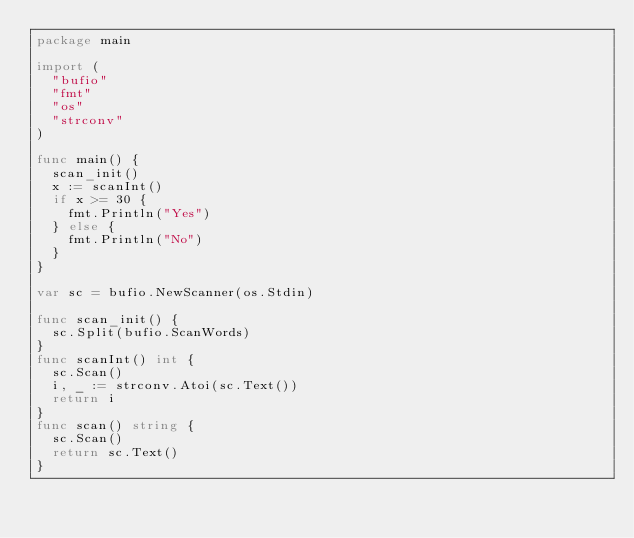<code> <loc_0><loc_0><loc_500><loc_500><_Go_>package main

import (
	"bufio"
	"fmt"
	"os"
	"strconv"
)

func main() {
	scan_init()
	x := scanInt()
	if x >= 30 {
		fmt.Println("Yes")
	} else {
		fmt.Println("No")
	}
}

var sc = bufio.NewScanner(os.Stdin)

func scan_init() {
	sc.Split(bufio.ScanWords)
}
func scanInt() int {
	sc.Scan()
	i, _ := strconv.Atoi(sc.Text())
	return i
}
func scan() string {
	sc.Scan()
	return sc.Text()
}</code> 